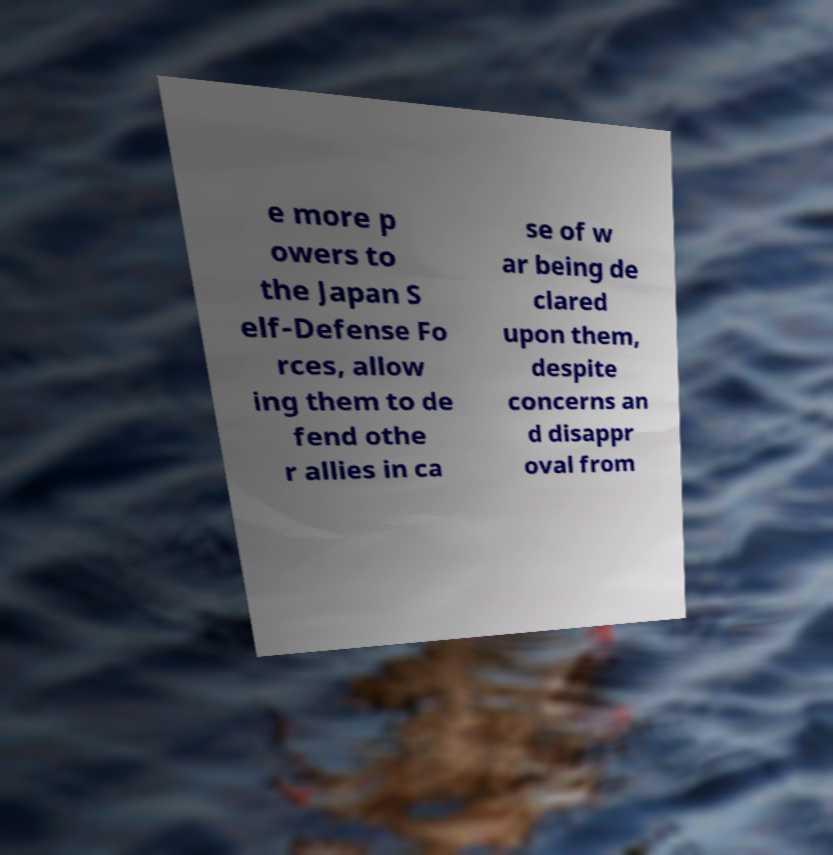Can you accurately transcribe the text from the provided image for me? e more p owers to the Japan S elf-Defense Fo rces, allow ing them to de fend othe r allies in ca se of w ar being de clared upon them, despite concerns an d disappr oval from 